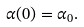Convert formula to latex. <formula><loc_0><loc_0><loc_500><loc_500>\alpha ( 0 ) = \alpha _ { 0 } .</formula> 